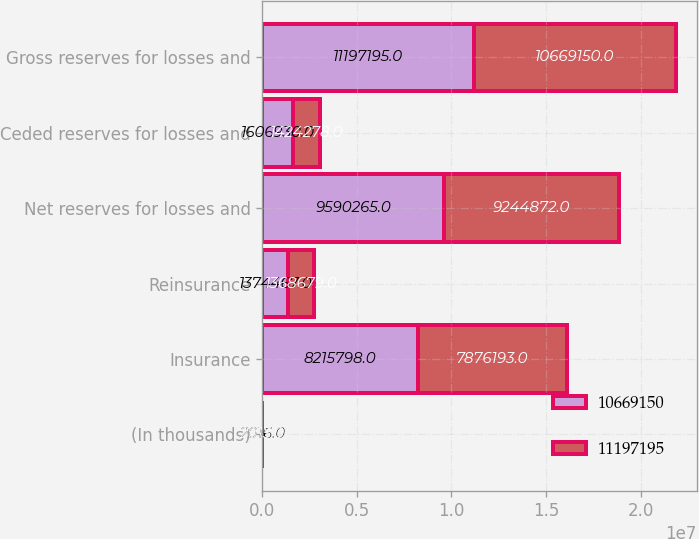<chart> <loc_0><loc_0><loc_500><loc_500><stacked_bar_chart><ecel><fcel>(In thousands)<fcel>Insurance<fcel>Reinsurance<fcel>Net reserves for losses and<fcel>Ceded reserves for losses and<fcel>Gross reserves for losses and<nl><fcel>1.06692e+07<fcel>2016<fcel>8.2158e+06<fcel>1.37447e+06<fcel>9.59026e+06<fcel>1.60693e+06<fcel>1.11972e+07<nl><fcel>1.11972e+07<fcel>2015<fcel>7.87619e+06<fcel>1.36868e+06<fcel>9.24487e+06<fcel>1.42428e+06<fcel>1.06692e+07<nl></chart> 